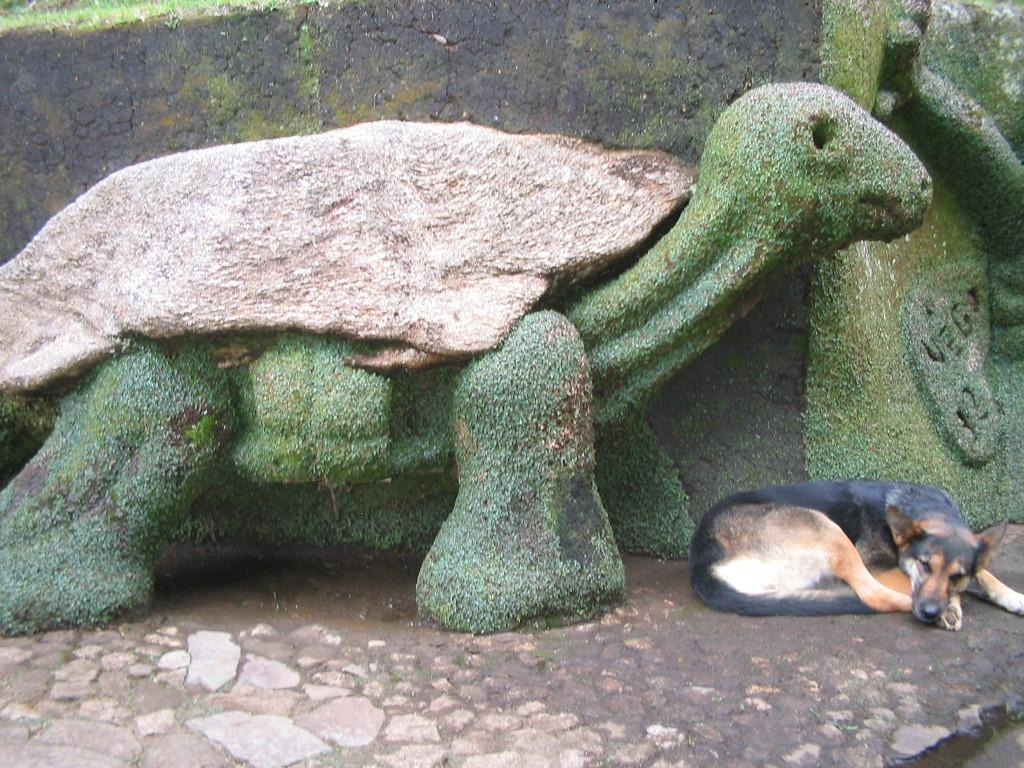What type of animal is in the image? There is a dog in the image. What is the dog doing in the image? The dog is sleeping. Can you describe the dog's coloring? The dog has brown, black, and white coloring. What can be seen in the background of the image? There is a statue of a tortoise in the background of the image. What colors are present on the statue? The statue has cream and green coloring. What type of plot is the dog involved in within the image? The image does not depict a plot or storyline, so there is no plot involving the dog. How many legs does the lawyer have in the image? There is no lawyer present in the image, so it is impossible to determine the number of legs they might have. 